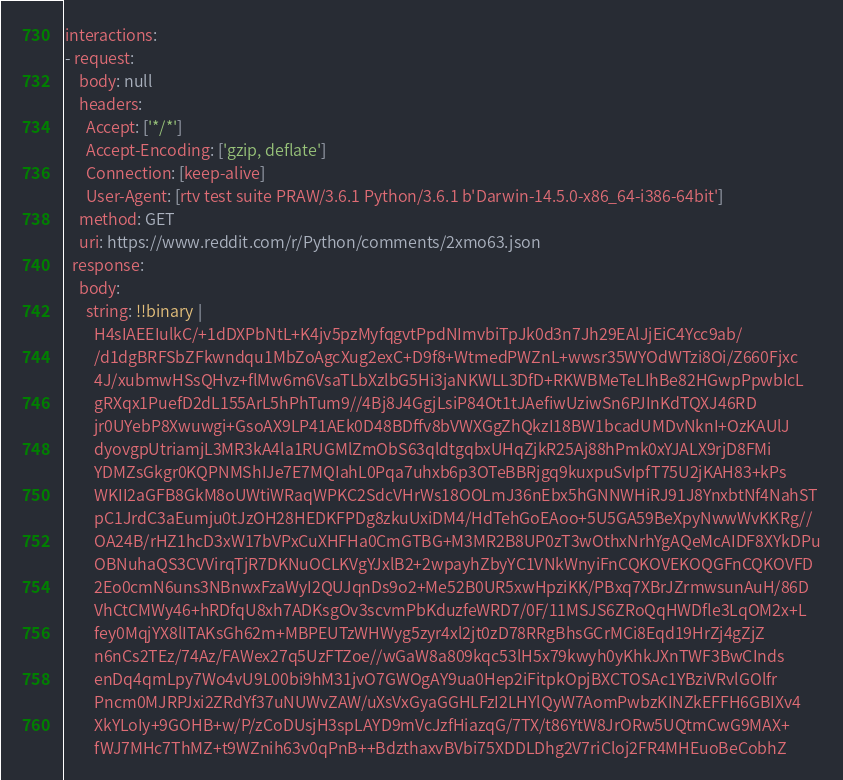<code> <loc_0><loc_0><loc_500><loc_500><_YAML_>interactions:
- request:
    body: null
    headers:
      Accept: ['*/*']
      Accept-Encoding: ['gzip, deflate']
      Connection: [keep-alive]
      User-Agent: [rtv test suite PRAW/3.6.1 Python/3.6.1 b'Darwin-14.5.0-x86_64-i386-64bit']
    method: GET
    uri: https://www.reddit.com/r/Python/comments/2xmo63.json
  response:
    body:
      string: !!binary |
        H4sIAEEIulkC/+1dDXPbNtL+K4jv5pzMyfqgvtPpdNImvbiTpJk0d3n7Jh29EAlJjEiC4Ycc9ab/
        /d1dgBRFSbZFkwndqu1MbZoAgcXug2exC+D9f8+WtmedPWZnL+wwsr35WYOdWTzi8Oi/Z660Fjxc
        4J/xubmwHSsQHvz+flMw6m6VsaTLbXzlbG5Hi3jaNKWLL3DfD+RKWBMeTeLIhBe82HGwpPpwbIcL
        gRXqx1PuefD2dL155ArL5hPhTum9//4Bj8J4GgjLsiP84Ot1tJAefiwUziwSn6PJInKdTQXJ46RD
        jr0UYebP8Xwuwgi+GsoAX9LP41AEk0D48BDffv8bVWXGgZhQkzI18BW1bcadUMDvNknI+OzKAUlJ
        dyovgpUtriamjL3MR3kA4la1RUGMlZmObS63qldtgqbxUHqZjkR25Aj88hPmk0xYJALX9rjD8FMi
        YDMZsGkgr0KQPNMShIJe7E7MQIahL0Pqa7uhxb6p3OTeBBRjgq9kuxpuSvIpfT75U2jKAH83+kPs
        WKII2aGFB8GkM8oUWtiWRaqWPKC2SdcVHrWs18OOLmJ36nEbx5hGNNWHiRJ91J8YnxbtNf4NahST
        pC1JrdC3aEumju0tJzOH28HEDKFPDg8zkuUxiDM4/HdTehGoEAoo+5U5GA59BeXpyNwwWvKKRg//
        OA24B/rHZ1hcD3xW17bVPxCuXHFHa0CmGTBG+M3MR2B8UP0zT3wOthxNrhYgAQeMcAIDF8XYkDPu
        OBNuhaQS3CVVirqTjR7DKNuOCLKVgYJxlB2+2wpayhZbyYC1VNkWnyiFnCQKOVEKOQGFnCQKOVFD
        2Eo0cmN6uns3NBnwxFzaWyI2QUJqnDs9o2+Me52B0UR5xwHpziKK/PBxq7XBrJZrmwsunAuH/86D
        VhCtCMWy46+hRDfqU8xh7ADKsgOv3scvmPbKduzfeWRD7/0F/11MSJS6ZRoQqHWDfle3LqOM2x+L
        fey0MqjYX8lITAKsGh62m+MBPEUTzWHWyg5zyr4xl2jt0zD78RRgBhsGCrMCi8Eqd19HrZj4gZjZ
        n6nCs2TEz/74Az/FAWex27q5UzFTZoe//wGaW8a809kqc53lH5x79kwyh0yKhkJXnTWF3BwCInds
        enDq4qmLpy7Wo4vU9L00bi9hM31jvO7GWOgAY9ua0Hep2iFitpkOpjBXCTOSAc1YBziVRvlGOlfr
        Pncm0MJRPJxi2ZRdYf37uNUWvZAW/uXsVxGyaGGHLFzI2LHYlQyW7AomPwbzKINZkEFFH6GBIXv4
        XkYLoIy+9GOHB+w/P/zCoDUsjH3spLAYD9mVcJzfHiazqG/7TX/t86YtW8JrORw5UQtmCwG9MAX+
        fWJ7MHc7ThMZ+t9WZnih63v0qPnB++BdzthaxvBVbi75XDDLDhg2V7riCloj2FR4MHEuoBeCobhZ</code> 